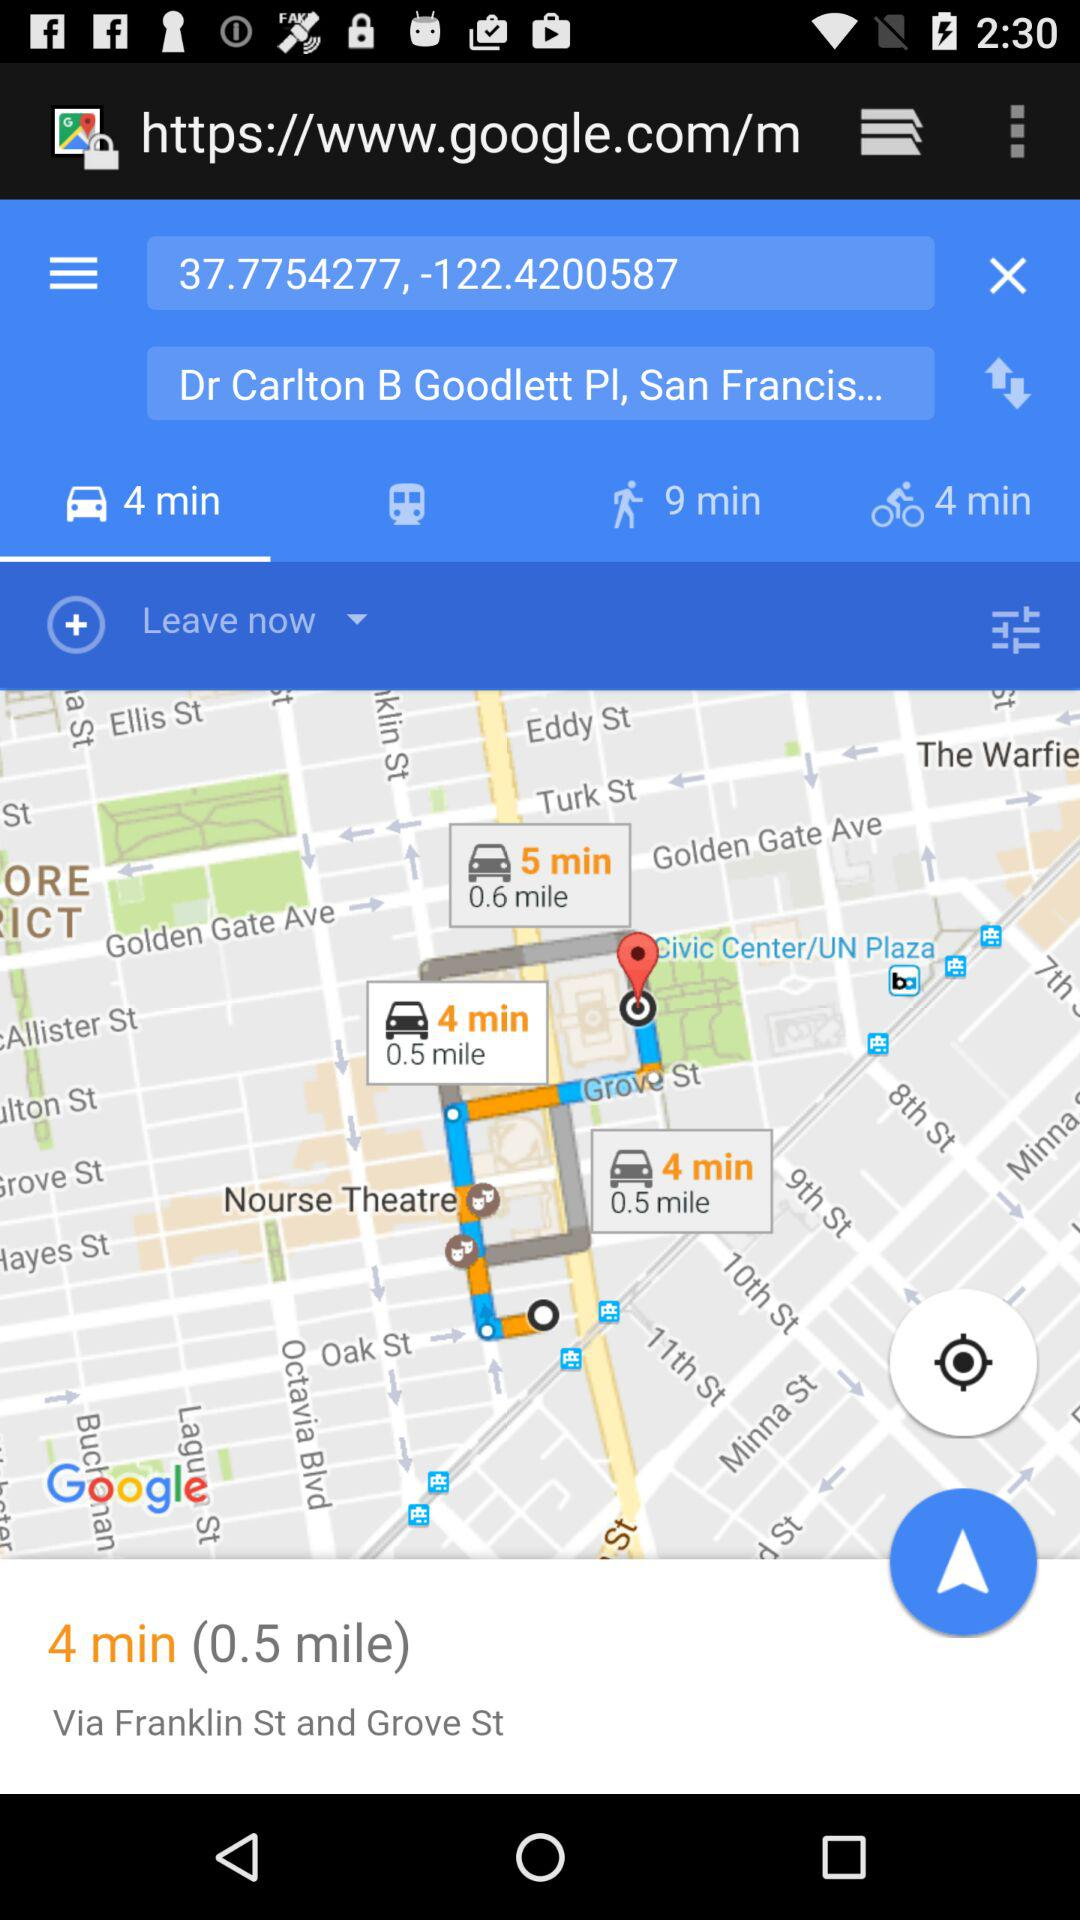How many minutes longer is the walking route than the bike route?
Answer the question using a single word or phrase. 5 